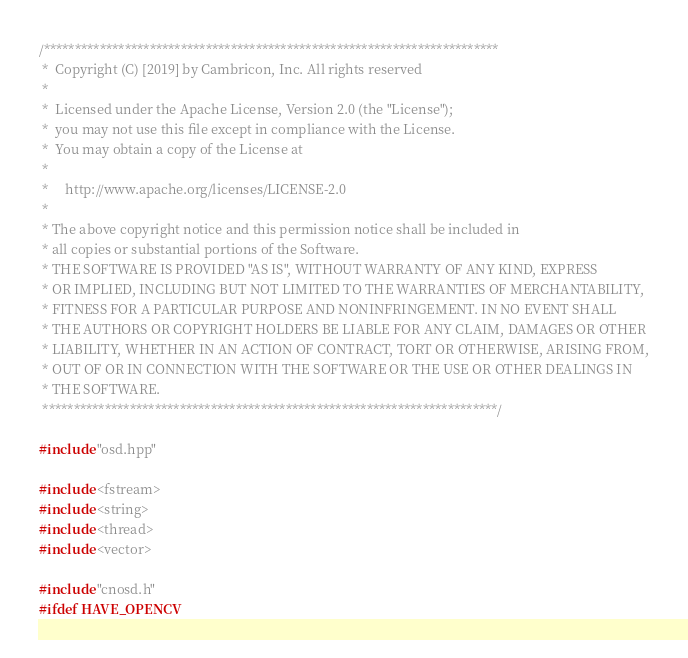Convert code to text. <code><loc_0><loc_0><loc_500><loc_500><_C++_>/*************************************************************************
 *  Copyright (C) [2019] by Cambricon, Inc. All rights reserved
 *
 *  Licensed under the Apache License, Version 2.0 (the "License");
 *  you may not use this file except in compliance with the License.
 *  You may obtain a copy of the License at
 *
 *     http://www.apache.org/licenses/LICENSE-2.0
 *
 * The above copyright notice and this permission notice shall be included in
 * all copies or substantial portions of the Software.
 * THE SOFTWARE IS PROVIDED "AS IS", WITHOUT WARRANTY OF ANY KIND, EXPRESS
 * OR IMPLIED, INCLUDING BUT NOT LIMITED TO THE WARRANTIES OF MERCHANTABILITY,
 * FITNESS FOR A PARTICULAR PURPOSE AND NONINFRINGEMENT. IN NO EVENT SHALL
 * THE AUTHORS OR COPYRIGHT HOLDERS BE LIABLE FOR ANY CLAIM, DAMAGES OR OTHER
 * LIABILITY, WHETHER IN AN ACTION OF CONTRACT, TORT OR OTHERWISE, ARISING FROM,
 * OUT OF OR IN CONNECTION WITH THE SOFTWARE OR THE USE OR OTHER DEALINGS IN
 * THE SOFTWARE.
 *************************************************************************/

#include "osd.hpp"

#include <fstream>
#include <string>
#include <thread>
#include <vector>

#include "cnosd.h"
#ifdef HAVE_OPENCV</code> 